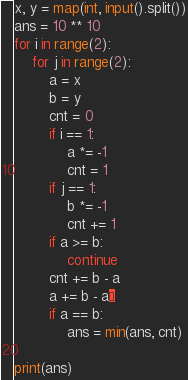<code> <loc_0><loc_0><loc_500><loc_500><_Python_>x, y = map(int, input().split())
ans = 10 ** 10
for i in range(2):
    for j in range(2):
        a = x
        b = y
        cnt = 0
        if i == 1:
            a *= -1
            cnt = 1
        if j == 1:
            b *= -1
            cnt += 1
        if a >= b:
            continue
        cnt += b - a
        a += b - a¥
        if a == b:
            ans = min(ans, cnt)

print(ans)
</code> 